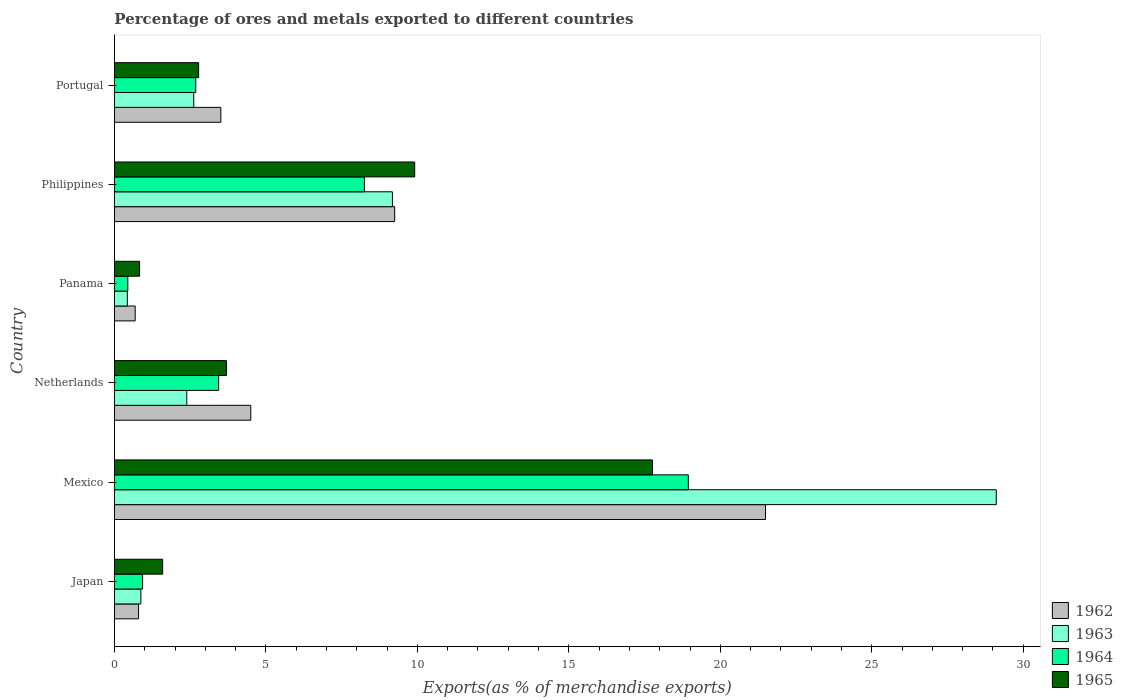Are the number of bars per tick equal to the number of legend labels?
Keep it short and to the point. Yes. Are the number of bars on each tick of the Y-axis equal?
Ensure brevity in your answer.  Yes. How many bars are there on the 5th tick from the top?
Make the answer very short. 4. What is the percentage of exports to different countries in 1962 in Panama?
Your response must be concise. 0.69. Across all countries, what is the maximum percentage of exports to different countries in 1965?
Offer a very short reply. 17.76. Across all countries, what is the minimum percentage of exports to different countries in 1964?
Give a very brief answer. 0.44. In which country was the percentage of exports to different countries in 1963 maximum?
Your answer should be very brief. Mexico. In which country was the percentage of exports to different countries in 1965 minimum?
Provide a short and direct response. Panama. What is the total percentage of exports to different countries in 1964 in the graph?
Offer a very short reply. 34.69. What is the difference between the percentage of exports to different countries in 1963 in Netherlands and that in Panama?
Make the answer very short. 1.96. What is the difference between the percentage of exports to different countries in 1964 in Japan and the percentage of exports to different countries in 1965 in Mexico?
Provide a short and direct response. -16.83. What is the average percentage of exports to different countries in 1962 per country?
Your response must be concise. 6.71. What is the difference between the percentage of exports to different countries in 1963 and percentage of exports to different countries in 1964 in Japan?
Provide a short and direct response. -0.06. In how many countries, is the percentage of exports to different countries in 1965 greater than 28 %?
Offer a terse response. 0. What is the ratio of the percentage of exports to different countries in 1962 in Mexico to that in Philippines?
Make the answer very short. 2.32. Is the difference between the percentage of exports to different countries in 1963 in Panama and Philippines greater than the difference between the percentage of exports to different countries in 1964 in Panama and Philippines?
Keep it short and to the point. No. What is the difference between the highest and the second highest percentage of exports to different countries in 1965?
Give a very brief answer. 7.85. What is the difference between the highest and the lowest percentage of exports to different countries in 1963?
Provide a short and direct response. 28.68. In how many countries, is the percentage of exports to different countries in 1963 greater than the average percentage of exports to different countries in 1963 taken over all countries?
Your answer should be very brief. 2. Is the sum of the percentage of exports to different countries in 1965 in Mexico and Netherlands greater than the maximum percentage of exports to different countries in 1964 across all countries?
Make the answer very short. Yes. Is it the case that in every country, the sum of the percentage of exports to different countries in 1964 and percentage of exports to different countries in 1962 is greater than the sum of percentage of exports to different countries in 1963 and percentage of exports to different countries in 1965?
Offer a terse response. No. What does the 1st bar from the top in Mexico represents?
Give a very brief answer. 1965. What does the 3rd bar from the bottom in Mexico represents?
Offer a very short reply. 1964. Is it the case that in every country, the sum of the percentage of exports to different countries in 1962 and percentage of exports to different countries in 1963 is greater than the percentage of exports to different countries in 1965?
Your answer should be very brief. Yes. Are all the bars in the graph horizontal?
Ensure brevity in your answer.  Yes. How many countries are there in the graph?
Provide a succinct answer. 6. Are the values on the major ticks of X-axis written in scientific E-notation?
Your answer should be compact. No. Does the graph contain grids?
Keep it short and to the point. No. Where does the legend appear in the graph?
Offer a very short reply. Bottom right. What is the title of the graph?
Keep it short and to the point. Percentage of ores and metals exported to different countries. What is the label or title of the X-axis?
Ensure brevity in your answer.  Exports(as % of merchandise exports). What is the label or title of the Y-axis?
Make the answer very short. Country. What is the Exports(as % of merchandise exports) in 1962 in Japan?
Provide a short and direct response. 0.8. What is the Exports(as % of merchandise exports) of 1963 in Japan?
Your response must be concise. 0.87. What is the Exports(as % of merchandise exports) in 1964 in Japan?
Provide a short and direct response. 0.93. What is the Exports(as % of merchandise exports) in 1965 in Japan?
Keep it short and to the point. 1.59. What is the Exports(as % of merchandise exports) of 1962 in Mexico?
Ensure brevity in your answer.  21.49. What is the Exports(as % of merchandise exports) of 1963 in Mexico?
Your answer should be compact. 29.11. What is the Exports(as % of merchandise exports) of 1964 in Mexico?
Provide a succinct answer. 18.94. What is the Exports(as % of merchandise exports) of 1965 in Mexico?
Make the answer very short. 17.76. What is the Exports(as % of merchandise exports) in 1962 in Netherlands?
Ensure brevity in your answer.  4.5. What is the Exports(as % of merchandise exports) of 1963 in Netherlands?
Offer a very short reply. 2.39. What is the Exports(as % of merchandise exports) in 1964 in Netherlands?
Your answer should be compact. 3.44. What is the Exports(as % of merchandise exports) in 1965 in Netherlands?
Give a very brief answer. 3.7. What is the Exports(as % of merchandise exports) in 1962 in Panama?
Your answer should be very brief. 0.69. What is the Exports(as % of merchandise exports) in 1963 in Panama?
Keep it short and to the point. 0.43. What is the Exports(as % of merchandise exports) of 1964 in Panama?
Provide a succinct answer. 0.44. What is the Exports(as % of merchandise exports) of 1965 in Panama?
Your answer should be compact. 0.83. What is the Exports(as % of merchandise exports) of 1962 in Philippines?
Your answer should be compact. 9.25. What is the Exports(as % of merchandise exports) of 1963 in Philippines?
Make the answer very short. 9.18. What is the Exports(as % of merchandise exports) in 1964 in Philippines?
Your response must be concise. 8.25. What is the Exports(as % of merchandise exports) of 1965 in Philippines?
Your response must be concise. 9.91. What is the Exports(as % of merchandise exports) in 1962 in Portugal?
Keep it short and to the point. 3.51. What is the Exports(as % of merchandise exports) of 1963 in Portugal?
Give a very brief answer. 2.62. What is the Exports(as % of merchandise exports) of 1964 in Portugal?
Provide a short and direct response. 2.69. What is the Exports(as % of merchandise exports) in 1965 in Portugal?
Offer a very short reply. 2.78. Across all countries, what is the maximum Exports(as % of merchandise exports) in 1962?
Provide a short and direct response. 21.49. Across all countries, what is the maximum Exports(as % of merchandise exports) of 1963?
Give a very brief answer. 29.11. Across all countries, what is the maximum Exports(as % of merchandise exports) in 1964?
Your answer should be compact. 18.94. Across all countries, what is the maximum Exports(as % of merchandise exports) in 1965?
Make the answer very short. 17.76. Across all countries, what is the minimum Exports(as % of merchandise exports) of 1962?
Make the answer very short. 0.69. Across all countries, what is the minimum Exports(as % of merchandise exports) of 1963?
Keep it short and to the point. 0.43. Across all countries, what is the minimum Exports(as % of merchandise exports) in 1964?
Provide a short and direct response. 0.44. Across all countries, what is the minimum Exports(as % of merchandise exports) in 1965?
Your answer should be compact. 0.83. What is the total Exports(as % of merchandise exports) in 1962 in the graph?
Provide a short and direct response. 40.24. What is the total Exports(as % of merchandise exports) of 1963 in the graph?
Give a very brief answer. 44.59. What is the total Exports(as % of merchandise exports) of 1964 in the graph?
Your answer should be very brief. 34.69. What is the total Exports(as % of merchandise exports) in 1965 in the graph?
Keep it short and to the point. 36.57. What is the difference between the Exports(as % of merchandise exports) in 1962 in Japan and that in Mexico?
Your answer should be very brief. -20.69. What is the difference between the Exports(as % of merchandise exports) of 1963 in Japan and that in Mexico?
Provide a short and direct response. -28.24. What is the difference between the Exports(as % of merchandise exports) in 1964 in Japan and that in Mexico?
Offer a very short reply. -18.01. What is the difference between the Exports(as % of merchandise exports) in 1965 in Japan and that in Mexico?
Provide a short and direct response. -16.17. What is the difference between the Exports(as % of merchandise exports) in 1962 in Japan and that in Netherlands?
Provide a succinct answer. -3.7. What is the difference between the Exports(as % of merchandise exports) in 1963 in Japan and that in Netherlands?
Offer a very short reply. -1.52. What is the difference between the Exports(as % of merchandise exports) of 1964 in Japan and that in Netherlands?
Your response must be concise. -2.51. What is the difference between the Exports(as % of merchandise exports) of 1965 in Japan and that in Netherlands?
Provide a succinct answer. -2.11. What is the difference between the Exports(as % of merchandise exports) of 1962 in Japan and that in Panama?
Provide a succinct answer. 0.11. What is the difference between the Exports(as % of merchandise exports) in 1963 in Japan and that in Panama?
Make the answer very short. 0.45. What is the difference between the Exports(as % of merchandise exports) of 1964 in Japan and that in Panama?
Offer a very short reply. 0.49. What is the difference between the Exports(as % of merchandise exports) in 1965 in Japan and that in Panama?
Give a very brief answer. 0.76. What is the difference between the Exports(as % of merchandise exports) of 1962 in Japan and that in Philippines?
Offer a terse response. -8.45. What is the difference between the Exports(as % of merchandise exports) in 1963 in Japan and that in Philippines?
Make the answer very short. -8.3. What is the difference between the Exports(as % of merchandise exports) in 1964 in Japan and that in Philippines?
Provide a succinct answer. -7.32. What is the difference between the Exports(as % of merchandise exports) in 1965 in Japan and that in Philippines?
Your answer should be very brief. -8.32. What is the difference between the Exports(as % of merchandise exports) of 1962 in Japan and that in Portugal?
Your response must be concise. -2.72. What is the difference between the Exports(as % of merchandise exports) in 1963 in Japan and that in Portugal?
Offer a terse response. -1.75. What is the difference between the Exports(as % of merchandise exports) of 1964 in Japan and that in Portugal?
Offer a terse response. -1.76. What is the difference between the Exports(as % of merchandise exports) of 1965 in Japan and that in Portugal?
Your answer should be compact. -1.19. What is the difference between the Exports(as % of merchandise exports) of 1962 in Mexico and that in Netherlands?
Provide a short and direct response. 16.99. What is the difference between the Exports(as % of merchandise exports) in 1963 in Mexico and that in Netherlands?
Your response must be concise. 26.72. What is the difference between the Exports(as % of merchandise exports) of 1964 in Mexico and that in Netherlands?
Provide a short and direct response. 15.5. What is the difference between the Exports(as % of merchandise exports) of 1965 in Mexico and that in Netherlands?
Your answer should be compact. 14.06. What is the difference between the Exports(as % of merchandise exports) in 1962 in Mexico and that in Panama?
Your response must be concise. 20.81. What is the difference between the Exports(as % of merchandise exports) of 1963 in Mexico and that in Panama?
Keep it short and to the point. 28.68. What is the difference between the Exports(as % of merchandise exports) of 1964 in Mexico and that in Panama?
Make the answer very short. 18.5. What is the difference between the Exports(as % of merchandise exports) of 1965 in Mexico and that in Panama?
Give a very brief answer. 16.93. What is the difference between the Exports(as % of merchandise exports) of 1962 in Mexico and that in Philippines?
Your answer should be compact. 12.24. What is the difference between the Exports(as % of merchandise exports) of 1963 in Mexico and that in Philippines?
Your answer should be very brief. 19.93. What is the difference between the Exports(as % of merchandise exports) of 1964 in Mexico and that in Philippines?
Make the answer very short. 10.69. What is the difference between the Exports(as % of merchandise exports) of 1965 in Mexico and that in Philippines?
Provide a short and direct response. 7.85. What is the difference between the Exports(as % of merchandise exports) in 1962 in Mexico and that in Portugal?
Give a very brief answer. 17.98. What is the difference between the Exports(as % of merchandise exports) in 1963 in Mexico and that in Portugal?
Your response must be concise. 26.49. What is the difference between the Exports(as % of merchandise exports) of 1964 in Mexico and that in Portugal?
Offer a very short reply. 16.26. What is the difference between the Exports(as % of merchandise exports) of 1965 in Mexico and that in Portugal?
Ensure brevity in your answer.  14.98. What is the difference between the Exports(as % of merchandise exports) in 1962 in Netherlands and that in Panama?
Your answer should be very brief. 3.82. What is the difference between the Exports(as % of merchandise exports) of 1963 in Netherlands and that in Panama?
Offer a terse response. 1.96. What is the difference between the Exports(as % of merchandise exports) of 1964 in Netherlands and that in Panama?
Offer a terse response. 3. What is the difference between the Exports(as % of merchandise exports) in 1965 in Netherlands and that in Panama?
Provide a succinct answer. 2.87. What is the difference between the Exports(as % of merchandise exports) in 1962 in Netherlands and that in Philippines?
Ensure brevity in your answer.  -4.75. What is the difference between the Exports(as % of merchandise exports) in 1963 in Netherlands and that in Philippines?
Offer a terse response. -6.79. What is the difference between the Exports(as % of merchandise exports) in 1964 in Netherlands and that in Philippines?
Provide a short and direct response. -4.81. What is the difference between the Exports(as % of merchandise exports) of 1965 in Netherlands and that in Philippines?
Offer a very short reply. -6.21. What is the difference between the Exports(as % of merchandise exports) in 1962 in Netherlands and that in Portugal?
Provide a short and direct response. 0.99. What is the difference between the Exports(as % of merchandise exports) of 1963 in Netherlands and that in Portugal?
Offer a terse response. -0.23. What is the difference between the Exports(as % of merchandise exports) in 1964 in Netherlands and that in Portugal?
Provide a short and direct response. 0.76. What is the difference between the Exports(as % of merchandise exports) of 1965 in Netherlands and that in Portugal?
Offer a very short reply. 0.92. What is the difference between the Exports(as % of merchandise exports) of 1962 in Panama and that in Philippines?
Make the answer very short. -8.56. What is the difference between the Exports(as % of merchandise exports) of 1963 in Panama and that in Philippines?
Provide a short and direct response. -8.75. What is the difference between the Exports(as % of merchandise exports) of 1964 in Panama and that in Philippines?
Offer a terse response. -7.81. What is the difference between the Exports(as % of merchandise exports) of 1965 in Panama and that in Philippines?
Offer a very short reply. -9.08. What is the difference between the Exports(as % of merchandise exports) in 1962 in Panama and that in Portugal?
Your answer should be compact. -2.83. What is the difference between the Exports(as % of merchandise exports) of 1963 in Panama and that in Portugal?
Your answer should be very brief. -2.19. What is the difference between the Exports(as % of merchandise exports) in 1964 in Panama and that in Portugal?
Offer a very short reply. -2.24. What is the difference between the Exports(as % of merchandise exports) in 1965 in Panama and that in Portugal?
Your answer should be very brief. -1.95. What is the difference between the Exports(as % of merchandise exports) in 1962 in Philippines and that in Portugal?
Offer a terse response. 5.74. What is the difference between the Exports(as % of merchandise exports) in 1963 in Philippines and that in Portugal?
Your answer should be very brief. 6.56. What is the difference between the Exports(as % of merchandise exports) of 1964 in Philippines and that in Portugal?
Make the answer very short. 5.57. What is the difference between the Exports(as % of merchandise exports) of 1965 in Philippines and that in Portugal?
Your answer should be compact. 7.13. What is the difference between the Exports(as % of merchandise exports) of 1962 in Japan and the Exports(as % of merchandise exports) of 1963 in Mexico?
Your answer should be very brief. -28.31. What is the difference between the Exports(as % of merchandise exports) of 1962 in Japan and the Exports(as % of merchandise exports) of 1964 in Mexico?
Your answer should be compact. -18.15. What is the difference between the Exports(as % of merchandise exports) of 1962 in Japan and the Exports(as % of merchandise exports) of 1965 in Mexico?
Provide a succinct answer. -16.97. What is the difference between the Exports(as % of merchandise exports) in 1963 in Japan and the Exports(as % of merchandise exports) in 1964 in Mexico?
Your response must be concise. -18.07. What is the difference between the Exports(as % of merchandise exports) in 1963 in Japan and the Exports(as % of merchandise exports) in 1965 in Mexico?
Provide a succinct answer. -16.89. What is the difference between the Exports(as % of merchandise exports) of 1964 in Japan and the Exports(as % of merchandise exports) of 1965 in Mexico?
Offer a terse response. -16.83. What is the difference between the Exports(as % of merchandise exports) in 1962 in Japan and the Exports(as % of merchandise exports) in 1963 in Netherlands?
Offer a terse response. -1.59. What is the difference between the Exports(as % of merchandise exports) of 1962 in Japan and the Exports(as % of merchandise exports) of 1964 in Netherlands?
Give a very brief answer. -2.64. What is the difference between the Exports(as % of merchandise exports) of 1962 in Japan and the Exports(as % of merchandise exports) of 1965 in Netherlands?
Your response must be concise. -2.9. What is the difference between the Exports(as % of merchandise exports) of 1963 in Japan and the Exports(as % of merchandise exports) of 1964 in Netherlands?
Offer a very short reply. -2.57. What is the difference between the Exports(as % of merchandise exports) of 1963 in Japan and the Exports(as % of merchandise exports) of 1965 in Netherlands?
Your answer should be very brief. -2.82. What is the difference between the Exports(as % of merchandise exports) in 1964 in Japan and the Exports(as % of merchandise exports) in 1965 in Netherlands?
Keep it short and to the point. -2.77. What is the difference between the Exports(as % of merchandise exports) of 1962 in Japan and the Exports(as % of merchandise exports) of 1963 in Panama?
Your response must be concise. 0.37. What is the difference between the Exports(as % of merchandise exports) of 1962 in Japan and the Exports(as % of merchandise exports) of 1964 in Panama?
Offer a very short reply. 0.35. What is the difference between the Exports(as % of merchandise exports) in 1962 in Japan and the Exports(as % of merchandise exports) in 1965 in Panama?
Your answer should be compact. -0.03. What is the difference between the Exports(as % of merchandise exports) of 1963 in Japan and the Exports(as % of merchandise exports) of 1964 in Panama?
Make the answer very short. 0.43. What is the difference between the Exports(as % of merchandise exports) in 1963 in Japan and the Exports(as % of merchandise exports) in 1965 in Panama?
Offer a terse response. 0.04. What is the difference between the Exports(as % of merchandise exports) of 1964 in Japan and the Exports(as % of merchandise exports) of 1965 in Panama?
Offer a very short reply. 0.1. What is the difference between the Exports(as % of merchandise exports) of 1962 in Japan and the Exports(as % of merchandise exports) of 1963 in Philippines?
Offer a terse response. -8.38. What is the difference between the Exports(as % of merchandise exports) in 1962 in Japan and the Exports(as % of merchandise exports) in 1964 in Philippines?
Your answer should be compact. -7.46. What is the difference between the Exports(as % of merchandise exports) in 1962 in Japan and the Exports(as % of merchandise exports) in 1965 in Philippines?
Offer a terse response. -9.12. What is the difference between the Exports(as % of merchandise exports) in 1963 in Japan and the Exports(as % of merchandise exports) in 1964 in Philippines?
Offer a very short reply. -7.38. What is the difference between the Exports(as % of merchandise exports) of 1963 in Japan and the Exports(as % of merchandise exports) of 1965 in Philippines?
Make the answer very short. -9.04. What is the difference between the Exports(as % of merchandise exports) of 1964 in Japan and the Exports(as % of merchandise exports) of 1965 in Philippines?
Make the answer very short. -8.98. What is the difference between the Exports(as % of merchandise exports) of 1962 in Japan and the Exports(as % of merchandise exports) of 1963 in Portugal?
Provide a succinct answer. -1.82. What is the difference between the Exports(as % of merchandise exports) in 1962 in Japan and the Exports(as % of merchandise exports) in 1964 in Portugal?
Provide a succinct answer. -1.89. What is the difference between the Exports(as % of merchandise exports) of 1962 in Japan and the Exports(as % of merchandise exports) of 1965 in Portugal?
Your answer should be compact. -1.98. What is the difference between the Exports(as % of merchandise exports) in 1963 in Japan and the Exports(as % of merchandise exports) in 1964 in Portugal?
Make the answer very short. -1.81. What is the difference between the Exports(as % of merchandise exports) of 1963 in Japan and the Exports(as % of merchandise exports) of 1965 in Portugal?
Provide a short and direct response. -1.91. What is the difference between the Exports(as % of merchandise exports) of 1964 in Japan and the Exports(as % of merchandise exports) of 1965 in Portugal?
Your answer should be compact. -1.85. What is the difference between the Exports(as % of merchandise exports) of 1962 in Mexico and the Exports(as % of merchandise exports) of 1963 in Netherlands?
Your answer should be compact. 19.1. What is the difference between the Exports(as % of merchandise exports) in 1962 in Mexico and the Exports(as % of merchandise exports) in 1964 in Netherlands?
Make the answer very short. 18.05. What is the difference between the Exports(as % of merchandise exports) in 1962 in Mexico and the Exports(as % of merchandise exports) in 1965 in Netherlands?
Provide a succinct answer. 17.79. What is the difference between the Exports(as % of merchandise exports) in 1963 in Mexico and the Exports(as % of merchandise exports) in 1964 in Netherlands?
Provide a succinct answer. 25.67. What is the difference between the Exports(as % of merchandise exports) in 1963 in Mexico and the Exports(as % of merchandise exports) in 1965 in Netherlands?
Your answer should be compact. 25.41. What is the difference between the Exports(as % of merchandise exports) in 1964 in Mexico and the Exports(as % of merchandise exports) in 1965 in Netherlands?
Ensure brevity in your answer.  15.25. What is the difference between the Exports(as % of merchandise exports) of 1962 in Mexico and the Exports(as % of merchandise exports) of 1963 in Panama?
Give a very brief answer. 21.06. What is the difference between the Exports(as % of merchandise exports) in 1962 in Mexico and the Exports(as % of merchandise exports) in 1964 in Panama?
Ensure brevity in your answer.  21.05. What is the difference between the Exports(as % of merchandise exports) of 1962 in Mexico and the Exports(as % of merchandise exports) of 1965 in Panama?
Keep it short and to the point. 20.66. What is the difference between the Exports(as % of merchandise exports) in 1963 in Mexico and the Exports(as % of merchandise exports) in 1964 in Panama?
Offer a very short reply. 28.67. What is the difference between the Exports(as % of merchandise exports) of 1963 in Mexico and the Exports(as % of merchandise exports) of 1965 in Panama?
Your response must be concise. 28.28. What is the difference between the Exports(as % of merchandise exports) of 1964 in Mexico and the Exports(as % of merchandise exports) of 1965 in Panama?
Give a very brief answer. 18.11. What is the difference between the Exports(as % of merchandise exports) in 1962 in Mexico and the Exports(as % of merchandise exports) in 1963 in Philippines?
Ensure brevity in your answer.  12.31. What is the difference between the Exports(as % of merchandise exports) of 1962 in Mexico and the Exports(as % of merchandise exports) of 1964 in Philippines?
Keep it short and to the point. 13.24. What is the difference between the Exports(as % of merchandise exports) in 1962 in Mexico and the Exports(as % of merchandise exports) in 1965 in Philippines?
Provide a succinct answer. 11.58. What is the difference between the Exports(as % of merchandise exports) in 1963 in Mexico and the Exports(as % of merchandise exports) in 1964 in Philippines?
Keep it short and to the point. 20.86. What is the difference between the Exports(as % of merchandise exports) of 1963 in Mexico and the Exports(as % of merchandise exports) of 1965 in Philippines?
Offer a terse response. 19.2. What is the difference between the Exports(as % of merchandise exports) in 1964 in Mexico and the Exports(as % of merchandise exports) in 1965 in Philippines?
Offer a very short reply. 9.03. What is the difference between the Exports(as % of merchandise exports) of 1962 in Mexico and the Exports(as % of merchandise exports) of 1963 in Portugal?
Make the answer very short. 18.87. What is the difference between the Exports(as % of merchandise exports) in 1962 in Mexico and the Exports(as % of merchandise exports) in 1964 in Portugal?
Your answer should be compact. 18.81. What is the difference between the Exports(as % of merchandise exports) of 1962 in Mexico and the Exports(as % of merchandise exports) of 1965 in Portugal?
Your answer should be compact. 18.71. What is the difference between the Exports(as % of merchandise exports) of 1963 in Mexico and the Exports(as % of merchandise exports) of 1964 in Portugal?
Offer a very short reply. 26.42. What is the difference between the Exports(as % of merchandise exports) of 1963 in Mexico and the Exports(as % of merchandise exports) of 1965 in Portugal?
Ensure brevity in your answer.  26.33. What is the difference between the Exports(as % of merchandise exports) in 1964 in Mexico and the Exports(as % of merchandise exports) in 1965 in Portugal?
Provide a short and direct response. 16.16. What is the difference between the Exports(as % of merchandise exports) of 1962 in Netherlands and the Exports(as % of merchandise exports) of 1963 in Panama?
Your response must be concise. 4.07. What is the difference between the Exports(as % of merchandise exports) in 1962 in Netherlands and the Exports(as % of merchandise exports) in 1964 in Panama?
Provide a short and direct response. 4.06. What is the difference between the Exports(as % of merchandise exports) in 1962 in Netherlands and the Exports(as % of merchandise exports) in 1965 in Panama?
Provide a short and direct response. 3.67. What is the difference between the Exports(as % of merchandise exports) in 1963 in Netherlands and the Exports(as % of merchandise exports) in 1964 in Panama?
Your answer should be compact. 1.95. What is the difference between the Exports(as % of merchandise exports) in 1963 in Netherlands and the Exports(as % of merchandise exports) in 1965 in Panama?
Make the answer very short. 1.56. What is the difference between the Exports(as % of merchandise exports) of 1964 in Netherlands and the Exports(as % of merchandise exports) of 1965 in Panama?
Keep it short and to the point. 2.61. What is the difference between the Exports(as % of merchandise exports) of 1962 in Netherlands and the Exports(as % of merchandise exports) of 1963 in Philippines?
Offer a terse response. -4.67. What is the difference between the Exports(as % of merchandise exports) of 1962 in Netherlands and the Exports(as % of merchandise exports) of 1964 in Philippines?
Ensure brevity in your answer.  -3.75. What is the difference between the Exports(as % of merchandise exports) of 1962 in Netherlands and the Exports(as % of merchandise exports) of 1965 in Philippines?
Make the answer very short. -5.41. What is the difference between the Exports(as % of merchandise exports) in 1963 in Netherlands and the Exports(as % of merchandise exports) in 1964 in Philippines?
Your answer should be compact. -5.86. What is the difference between the Exports(as % of merchandise exports) of 1963 in Netherlands and the Exports(as % of merchandise exports) of 1965 in Philippines?
Offer a terse response. -7.52. What is the difference between the Exports(as % of merchandise exports) in 1964 in Netherlands and the Exports(as % of merchandise exports) in 1965 in Philippines?
Give a very brief answer. -6.47. What is the difference between the Exports(as % of merchandise exports) of 1962 in Netherlands and the Exports(as % of merchandise exports) of 1963 in Portugal?
Your answer should be compact. 1.88. What is the difference between the Exports(as % of merchandise exports) of 1962 in Netherlands and the Exports(as % of merchandise exports) of 1964 in Portugal?
Offer a very short reply. 1.82. What is the difference between the Exports(as % of merchandise exports) in 1962 in Netherlands and the Exports(as % of merchandise exports) in 1965 in Portugal?
Your answer should be very brief. 1.72. What is the difference between the Exports(as % of merchandise exports) in 1963 in Netherlands and the Exports(as % of merchandise exports) in 1964 in Portugal?
Keep it short and to the point. -0.3. What is the difference between the Exports(as % of merchandise exports) of 1963 in Netherlands and the Exports(as % of merchandise exports) of 1965 in Portugal?
Make the answer very short. -0.39. What is the difference between the Exports(as % of merchandise exports) in 1964 in Netherlands and the Exports(as % of merchandise exports) in 1965 in Portugal?
Your response must be concise. 0.66. What is the difference between the Exports(as % of merchandise exports) of 1962 in Panama and the Exports(as % of merchandise exports) of 1963 in Philippines?
Make the answer very short. -8.49. What is the difference between the Exports(as % of merchandise exports) of 1962 in Panama and the Exports(as % of merchandise exports) of 1964 in Philippines?
Your response must be concise. -7.57. What is the difference between the Exports(as % of merchandise exports) of 1962 in Panama and the Exports(as % of merchandise exports) of 1965 in Philippines?
Your response must be concise. -9.23. What is the difference between the Exports(as % of merchandise exports) of 1963 in Panama and the Exports(as % of merchandise exports) of 1964 in Philippines?
Provide a short and direct response. -7.83. What is the difference between the Exports(as % of merchandise exports) in 1963 in Panama and the Exports(as % of merchandise exports) in 1965 in Philippines?
Your answer should be compact. -9.49. What is the difference between the Exports(as % of merchandise exports) of 1964 in Panama and the Exports(as % of merchandise exports) of 1965 in Philippines?
Your answer should be very brief. -9.47. What is the difference between the Exports(as % of merchandise exports) of 1962 in Panama and the Exports(as % of merchandise exports) of 1963 in Portugal?
Offer a terse response. -1.93. What is the difference between the Exports(as % of merchandise exports) of 1962 in Panama and the Exports(as % of merchandise exports) of 1964 in Portugal?
Your answer should be very brief. -2. What is the difference between the Exports(as % of merchandise exports) of 1962 in Panama and the Exports(as % of merchandise exports) of 1965 in Portugal?
Make the answer very short. -2.09. What is the difference between the Exports(as % of merchandise exports) in 1963 in Panama and the Exports(as % of merchandise exports) in 1964 in Portugal?
Ensure brevity in your answer.  -2.26. What is the difference between the Exports(as % of merchandise exports) of 1963 in Panama and the Exports(as % of merchandise exports) of 1965 in Portugal?
Give a very brief answer. -2.35. What is the difference between the Exports(as % of merchandise exports) of 1964 in Panama and the Exports(as % of merchandise exports) of 1965 in Portugal?
Give a very brief answer. -2.34. What is the difference between the Exports(as % of merchandise exports) in 1962 in Philippines and the Exports(as % of merchandise exports) in 1963 in Portugal?
Your answer should be very brief. 6.63. What is the difference between the Exports(as % of merchandise exports) in 1962 in Philippines and the Exports(as % of merchandise exports) in 1964 in Portugal?
Provide a succinct answer. 6.56. What is the difference between the Exports(as % of merchandise exports) in 1962 in Philippines and the Exports(as % of merchandise exports) in 1965 in Portugal?
Ensure brevity in your answer.  6.47. What is the difference between the Exports(as % of merchandise exports) in 1963 in Philippines and the Exports(as % of merchandise exports) in 1964 in Portugal?
Provide a short and direct response. 6.49. What is the difference between the Exports(as % of merchandise exports) of 1963 in Philippines and the Exports(as % of merchandise exports) of 1965 in Portugal?
Offer a very short reply. 6.4. What is the difference between the Exports(as % of merchandise exports) in 1964 in Philippines and the Exports(as % of merchandise exports) in 1965 in Portugal?
Your answer should be very brief. 5.47. What is the average Exports(as % of merchandise exports) of 1962 per country?
Ensure brevity in your answer.  6.71. What is the average Exports(as % of merchandise exports) of 1963 per country?
Ensure brevity in your answer.  7.43. What is the average Exports(as % of merchandise exports) of 1964 per country?
Provide a succinct answer. 5.78. What is the average Exports(as % of merchandise exports) of 1965 per country?
Your answer should be very brief. 6.1. What is the difference between the Exports(as % of merchandise exports) of 1962 and Exports(as % of merchandise exports) of 1963 in Japan?
Give a very brief answer. -0.08. What is the difference between the Exports(as % of merchandise exports) in 1962 and Exports(as % of merchandise exports) in 1964 in Japan?
Give a very brief answer. -0.13. What is the difference between the Exports(as % of merchandise exports) of 1962 and Exports(as % of merchandise exports) of 1965 in Japan?
Provide a short and direct response. -0.8. What is the difference between the Exports(as % of merchandise exports) in 1963 and Exports(as % of merchandise exports) in 1964 in Japan?
Provide a short and direct response. -0.06. What is the difference between the Exports(as % of merchandise exports) in 1963 and Exports(as % of merchandise exports) in 1965 in Japan?
Give a very brief answer. -0.72. What is the difference between the Exports(as % of merchandise exports) in 1964 and Exports(as % of merchandise exports) in 1965 in Japan?
Offer a very short reply. -0.66. What is the difference between the Exports(as % of merchandise exports) of 1962 and Exports(as % of merchandise exports) of 1963 in Mexico?
Your response must be concise. -7.62. What is the difference between the Exports(as % of merchandise exports) of 1962 and Exports(as % of merchandise exports) of 1964 in Mexico?
Give a very brief answer. 2.55. What is the difference between the Exports(as % of merchandise exports) of 1962 and Exports(as % of merchandise exports) of 1965 in Mexico?
Offer a terse response. 3.73. What is the difference between the Exports(as % of merchandise exports) in 1963 and Exports(as % of merchandise exports) in 1964 in Mexico?
Keep it short and to the point. 10.16. What is the difference between the Exports(as % of merchandise exports) in 1963 and Exports(as % of merchandise exports) in 1965 in Mexico?
Offer a terse response. 11.35. What is the difference between the Exports(as % of merchandise exports) of 1964 and Exports(as % of merchandise exports) of 1965 in Mexico?
Offer a very short reply. 1.18. What is the difference between the Exports(as % of merchandise exports) in 1962 and Exports(as % of merchandise exports) in 1963 in Netherlands?
Give a very brief answer. 2.11. What is the difference between the Exports(as % of merchandise exports) of 1962 and Exports(as % of merchandise exports) of 1964 in Netherlands?
Give a very brief answer. 1.06. What is the difference between the Exports(as % of merchandise exports) in 1962 and Exports(as % of merchandise exports) in 1965 in Netherlands?
Provide a short and direct response. 0.8. What is the difference between the Exports(as % of merchandise exports) of 1963 and Exports(as % of merchandise exports) of 1964 in Netherlands?
Offer a very short reply. -1.05. What is the difference between the Exports(as % of merchandise exports) in 1963 and Exports(as % of merchandise exports) in 1965 in Netherlands?
Give a very brief answer. -1.31. What is the difference between the Exports(as % of merchandise exports) of 1964 and Exports(as % of merchandise exports) of 1965 in Netherlands?
Provide a succinct answer. -0.26. What is the difference between the Exports(as % of merchandise exports) in 1962 and Exports(as % of merchandise exports) in 1963 in Panama?
Your answer should be compact. 0.26. What is the difference between the Exports(as % of merchandise exports) in 1962 and Exports(as % of merchandise exports) in 1964 in Panama?
Your answer should be compact. 0.24. What is the difference between the Exports(as % of merchandise exports) in 1962 and Exports(as % of merchandise exports) in 1965 in Panama?
Keep it short and to the point. -0.15. What is the difference between the Exports(as % of merchandise exports) in 1963 and Exports(as % of merchandise exports) in 1964 in Panama?
Keep it short and to the point. -0.02. What is the difference between the Exports(as % of merchandise exports) of 1963 and Exports(as % of merchandise exports) of 1965 in Panama?
Ensure brevity in your answer.  -0.4. What is the difference between the Exports(as % of merchandise exports) of 1964 and Exports(as % of merchandise exports) of 1965 in Panama?
Offer a terse response. -0.39. What is the difference between the Exports(as % of merchandise exports) of 1962 and Exports(as % of merchandise exports) of 1963 in Philippines?
Offer a very short reply. 0.07. What is the difference between the Exports(as % of merchandise exports) in 1962 and Exports(as % of merchandise exports) in 1964 in Philippines?
Your answer should be compact. 1. What is the difference between the Exports(as % of merchandise exports) of 1962 and Exports(as % of merchandise exports) of 1965 in Philippines?
Your answer should be compact. -0.66. What is the difference between the Exports(as % of merchandise exports) in 1963 and Exports(as % of merchandise exports) in 1964 in Philippines?
Offer a very short reply. 0.92. What is the difference between the Exports(as % of merchandise exports) in 1963 and Exports(as % of merchandise exports) in 1965 in Philippines?
Give a very brief answer. -0.74. What is the difference between the Exports(as % of merchandise exports) of 1964 and Exports(as % of merchandise exports) of 1965 in Philippines?
Offer a terse response. -1.66. What is the difference between the Exports(as % of merchandise exports) in 1962 and Exports(as % of merchandise exports) in 1963 in Portugal?
Offer a very short reply. 0.89. What is the difference between the Exports(as % of merchandise exports) of 1962 and Exports(as % of merchandise exports) of 1964 in Portugal?
Provide a succinct answer. 0.83. What is the difference between the Exports(as % of merchandise exports) in 1962 and Exports(as % of merchandise exports) in 1965 in Portugal?
Your response must be concise. 0.73. What is the difference between the Exports(as % of merchandise exports) in 1963 and Exports(as % of merchandise exports) in 1964 in Portugal?
Ensure brevity in your answer.  -0.07. What is the difference between the Exports(as % of merchandise exports) of 1963 and Exports(as % of merchandise exports) of 1965 in Portugal?
Your response must be concise. -0.16. What is the difference between the Exports(as % of merchandise exports) in 1964 and Exports(as % of merchandise exports) in 1965 in Portugal?
Make the answer very short. -0.09. What is the ratio of the Exports(as % of merchandise exports) in 1962 in Japan to that in Mexico?
Your answer should be compact. 0.04. What is the ratio of the Exports(as % of merchandise exports) in 1964 in Japan to that in Mexico?
Give a very brief answer. 0.05. What is the ratio of the Exports(as % of merchandise exports) in 1965 in Japan to that in Mexico?
Your answer should be very brief. 0.09. What is the ratio of the Exports(as % of merchandise exports) in 1962 in Japan to that in Netherlands?
Your response must be concise. 0.18. What is the ratio of the Exports(as % of merchandise exports) of 1963 in Japan to that in Netherlands?
Your answer should be very brief. 0.37. What is the ratio of the Exports(as % of merchandise exports) of 1964 in Japan to that in Netherlands?
Your answer should be compact. 0.27. What is the ratio of the Exports(as % of merchandise exports) of 1965 in Japan to that in Netherlands?
Offer a terse response. 0.43. What is the ratio of the Exports(as % of merchandise exports) in 1962 in Japan to that in Panama?
Your answer should be very brief. 1.16. What is the ratio of the Exports(as % of merchandise exports) in 1963 in Japan to that in Panama?
Offer a terse response. 2.05. What is the ratio of the Exports(as % of merchandise exports) of 1964 in Japan to that in Panama?
Make the answer very short. 2.1. What is the ratio of the Exports(as % of merchandise exports) in 1965 in Japan to that in Panama?
Make the answer very short. 1.92. What is the ratio of the Exports(as % of merchandise exports) in 1962 in Japan to that in Philippines?
Give a very brief answer. 0.09. What is the ratio of the Exports(as % of merchandise exports) in 1963 in Japan to that in Philippines?
Your response must be concise. 0.1. What is the ratio of the Exports(as % of merchandise exports) of 1964 in Japan to that in Philippines?
Provide a short and direct response. 0.11. What is the ratio of the Exports(as % of merchandise exports) in 1965 in Japan to that in Philippines?
Give a very brief answer. 0.16. What is the ratio of the Exports(as % of merchandise exports) of 1962 in Japan to that in Portugal?
Make the answer very short. 0.23. What is the ratio of the Exports(as % of merchandise exports) of 1963 in Japan to that in Portugal?
Your response must be concise. 0.33. What is the ratio of the Exports(as % of merchandise exports) in 1964 in Japan to that in Portugal?
Your answer should be compact. 0.35. What is the ratio of the Exports(as % of merchandise exports) in 1965 in Japan to that in Portugal?
Provide a succinct answer. 0.57. What is the ratio of the Exports(as % of merchandise exports) of 1962 in Mexico to that in Netherlands?
Keep it short and to the point. 4.77. What is the ratio of the Exports(as % of merchandise exports) in 1963 in Mexico to that in Netherlands?
Provide a short and direct response. 12.18. What is the ratio of the Exports(as % of merchandise exports) of 1964 in Mexico to that in Netherlands?
Give a very brief answer. 5.51. What is the ratio of the Exports(as % of merchandise exports) of 1965 in Mexico to that in Netherlands?
Provide a short and direct response. 4.8. What is the ratio of the Exports(as % of merchandise exports) of 1962 in Mexico to that in Panama?
Your answer should be compact. 31.37. What is the ratio of the Exports(as % of merchandise exports) of 1963 in Mexico to that in Panama?
Provide a short and direct response. 68.27. What is the ratio of the Exports(as % of merchandise exports) of 1964 in Mexico to that in Panama?
Provide a short and direct response. 42.84. What is the ratio of the Exports(as % of merchandise exports) of 1965 in Mexico to that in Panama?
Keep it short and to the point. 21.38. What is the ratio of the Exports(as % of merchandise exports) of 1962 in Mexico to that in Philippines?
Make the answer very short. 2.32. What is the ratio of the Exports(as % of merchandise exports) of 1963 in Mexico to that in Philippines?
Offer a terse response. 3.17. What is the ratio of the Exports(as % of merchandise exports) in 1964 in Mexico to that in Philippines?
Provide a succinct answer. 2.3. What is the ratio of the Exports(as % of merchandise exports) of 1965 in Mexico to that in Philippines?
Make the answer very short. 1.79. What is the ratio of the Exports(as % of merchandise exports) of 1962 in Mexico to that in Portugal?
Your answer should be compact. 6.12. What is the ratio of the Exports(as % of merchandise exports) of 1963 in Mexico to that in Portugal?
Ensure brevity in your answer.  11.12. What is the ratio of the Exports(as % of merchandise exports) of 1964 in Mexico to that in Portugal?
Offer a terse response. 7.05. What is the ratio of the Exports(as % of merchandise exports) in 1965 in Mexico to that in Portugal?
Provide a succinct answer. 6.39. What is the ratio of the Exports(as % of merchandise exports) of 1962 in Netherlands to that in Panama?
Your answer should be compact. 6.57. What is the ratio of the Exports(as % of merchandise exports) in 1963 in Netherlands to that in Panama?
Provide a short and direct response. 5.6. What is the ratio of the Exports(as % of merchandise exports) of 1964 in Netherlands to that in Panama?
Ensure brevity in your answer.  7.78. What is the ratio of the Exports(as % of merchandise exports) in 1965 in Netherlands to that in Panama?
Your response must be concise. 4.45. What is the ratio of the Exports(as % of merchandise exports) of 1962 in Netherlands to that in Philippines?
Give a very brief answer. 0.49. What is the ratio of the Exports(as % of merchandise exports) in 1963 in Netherlands to that in Philippines?
Offer a very short reply. 0.26. What is the ratio of the Exports(as % of merchandise exports) in 1964 in Netherlands to that in Philippines?
Provide a succinct answer. 0.42. What is the ratio of the Exports(as % of merchandise exports) in 1965 in Netherlands to that in Philippines?
Give a very brief answer. 0.37. What is the ratio of the Exports(as % of merchandise exports) of 1962 in Netherlands to that in Portugal?
Your response must be concise. 1.28. What is the ratio of the Exports(as % of merchandise exports) of 1963 in Netherlands to that in Portugal?
Provide a short and direct response. 0.91. What is the ratio of the Exports(as % of merchandise exports) of 1964 in Netherlands to that in Portugal?
Offer a terse response. 1.28. What is the ratio of the Exports(as % of merchandise exports) in 1965 in Netherlands to that in Portugal?
Your answer should be very brief. 1.33. What is the ratio of the Exports(as % of merchandise exports) in 1962 in Panama to that in Philippines?
Ensure brevity in your answer.  0.07. What is the ratio of the Exports(as % of merchandise exports) in 1963 in Panama to that in Philippines?
Make the answer very short. 0.05. What is the ratio of the Exports(as % of merchandise exports) of 1964 in Panama to that in Philippines?
Ensure brevity in your answer.  0.05. What is the ratio of the Exports(as % of merchandise exports) in 1965 in Panama to that in Philippines?
Make the answer very short. 0.08. What is the ratio of the Exports(as % of merchandise exports) in 1962 in Panama to that in Portugal?
Keep it short and to the point. 0.2. What is the ratio of the Exports(as % of merchandise exports) in 1963 in Panama to that in Portugal?
Your answer should be compact. 0.16. What is the ratio of the Exports(as % of merchandise exports) in 1964 in Panama to that in Portugal?
Offer a terse response. 0.16. What is the ratio of the Exports(as % of merchandise exports) in 1965 in Panama to that in Portugal?
Your answer should be compact. 0.3. What is the ratio of the Exports(as % of merchandise exports) of 1962 in Philippines to that in Portugal?
Ensure brevity in your answer.  2.63. What is the ratio of the Exports(as % of merchandise exports) of 1963 in Philippines to that in Portugal?
Provide a succinct answer. 3.5. What is the ratio of the Exports(as % of merchandise exports) of 1964 in Philippines to that in Portugal?
Offer a very short reply. 3.07. What is the ratio of the Exports(as % of merchandise exports) of 1965 in Philippines to that in Portugal?
Give a very brief answer. 3.57. What is the difference between the highest and the second highest Exports(as % of merchandise exports) of 1962?
Your answer should be very brief. 12.24. What is the difference between the highest and the second highest Exports(as % of merchandise exports) of 1963?
Provide a succinct answer. 19.93. What is the difference between the highest and the second highest Exports(as % of merchandise exports) in 1964?
Give a very brief answer. 10.69. What is the difference between the highest and the second highest Exports(as % of merchandise exports) of 1965?
Your answer should be very brief. 7.85. What is the difference between the highest and the lowest Exports(as % of merchandise exports) of 1962?
Offer a terse response. 20.81. What is the difference between the highest and the lowest Exports(as % of merchandise exports) in 1963?
Give a very brief answer. 28.68. What is the difference between the highest and the lowest Exports(as % of merchandise exports) in 1964?
Provide a succinct answer. 18.5. What is the difference between the highest and the lowest Exports(as % of merchandise exports) of 1965?
Your answer should be compact. 16.93. 